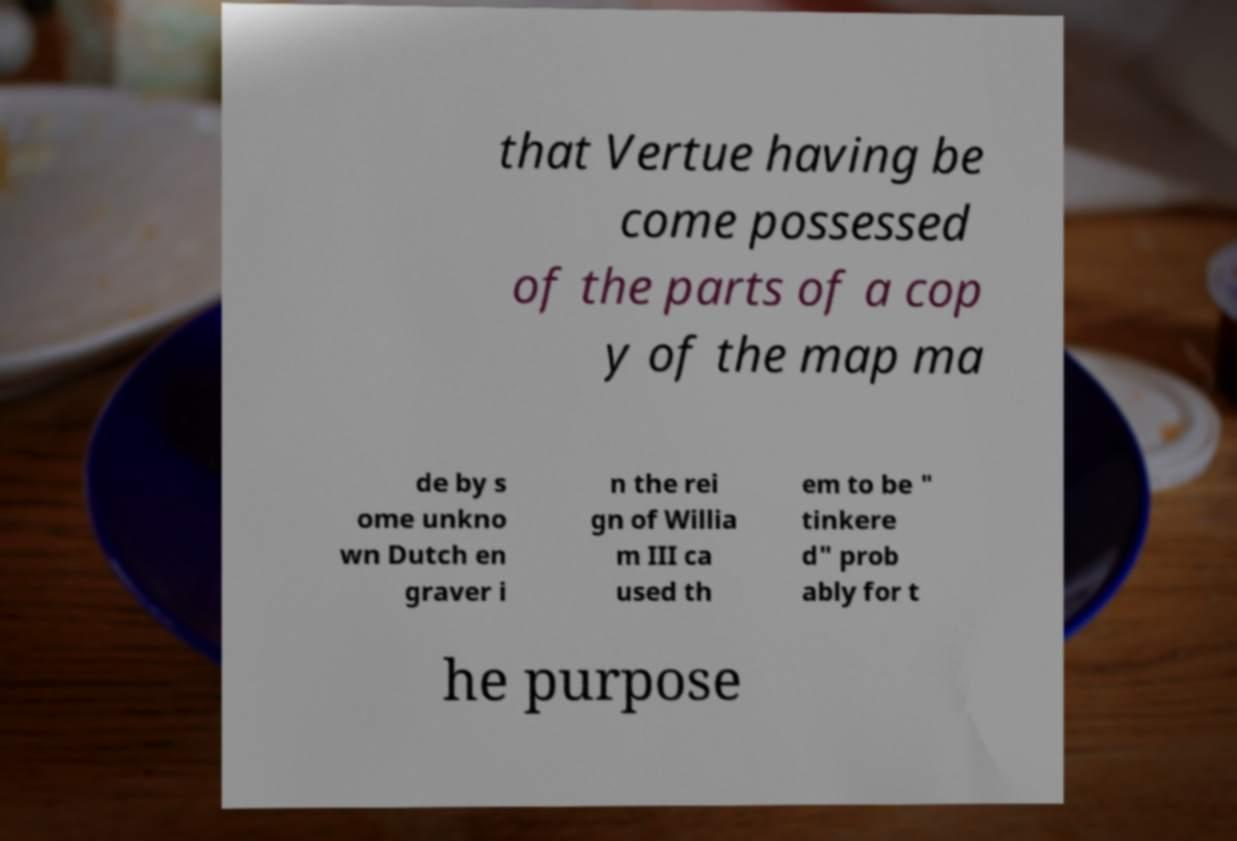Could you assist in decoding the text presented in this image and type it out clearly? that Vertue having be come possessed of the parts of a cop y of the map ma de by s ome unkno wn Dutch en graver i n the rei gn of Willia m III ca used th em to be " tinkere d" prob ably for t he purpose 